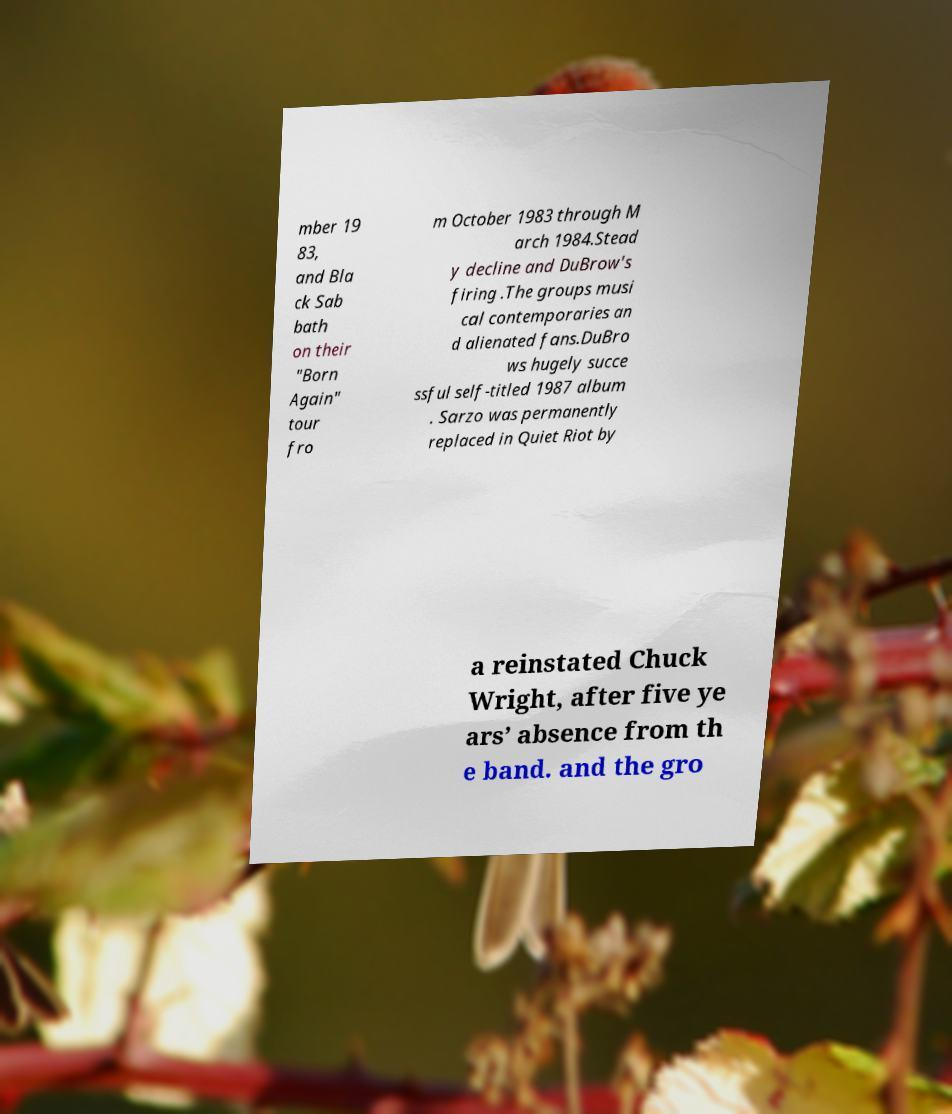Can you accurately transcribe the text from the provided image for me? mber 19 83, and Bla ck Sab bath on their "Born Again" tour fro m October 1983 through M arch 1984.Stead y decline and DuBrow's firing .The groups musi cal contemporaries an d alienated fans.DuBro ws hugely succe ssful self-titled 1987 album . Sarzo was permanently replaced in Quiet Riot by a reinstated Chuck Wright, after five ye ars’ absence from th e band. and the gro 